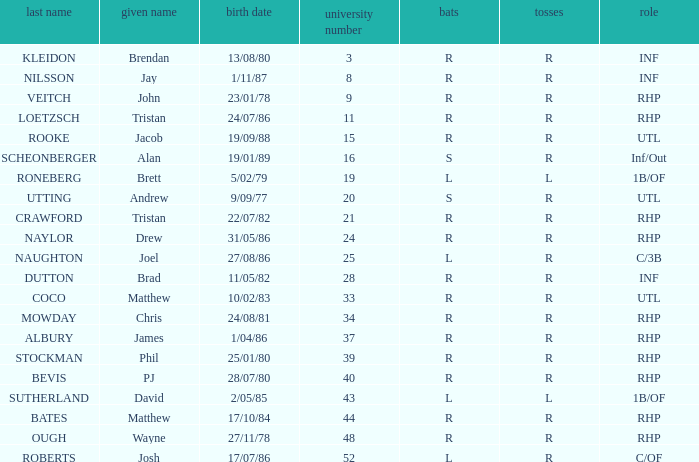Which First has a Uni # larger than 34, and Throws of r, and a Position of rhp, and a Surname of stockman? Phil. 